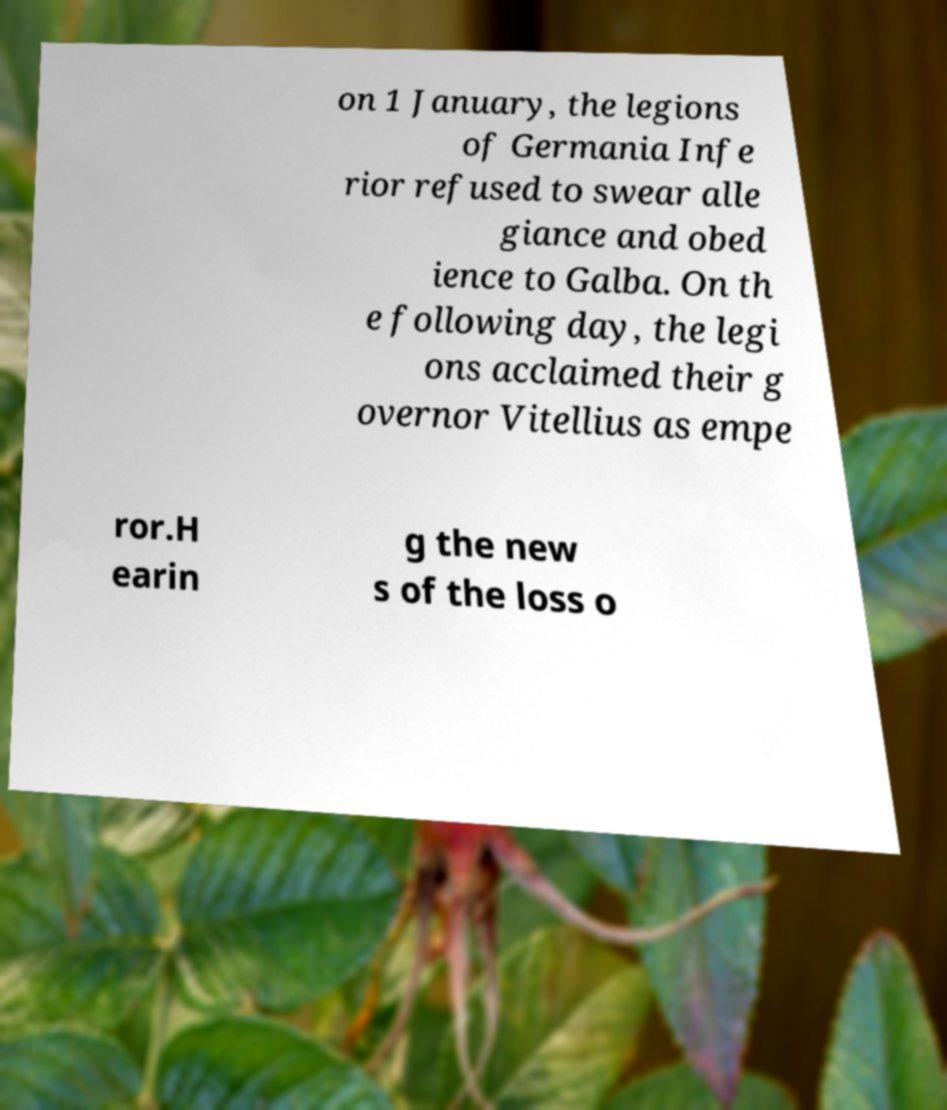Please identify and transcribe the text found in this image. on 1 January, the legions of Germania Infe rior refused to swear alle giance and obed ience to Galba. On th e following day, the legi ons acclaimed their g overnor Vitellius as empe ror.H earin g the new s of the loss o 